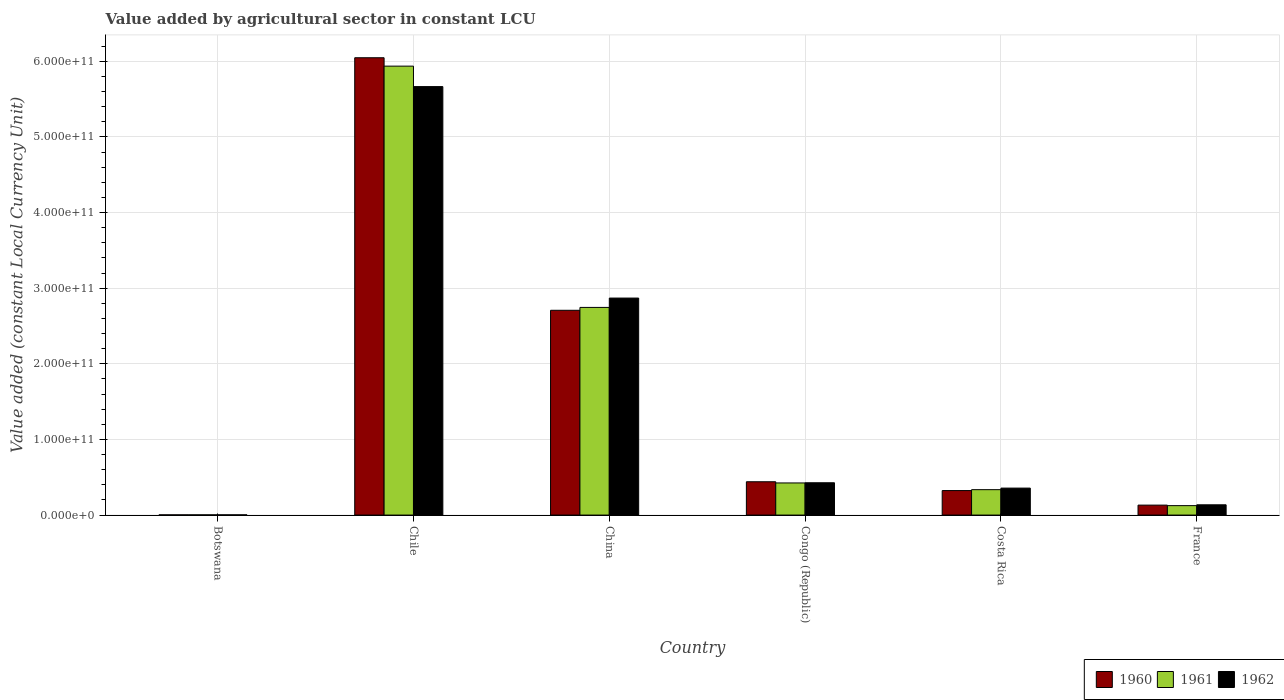How many different coloured bars are there?
Your response must be concise. 3. Are the number of bars per tick equal to the number of legend labels?
Offer a very short reply. Yes. Are the number of bars on each tick of the X-axis equal?
Provide a succinct answer. Yes. How many bars are there on the 4th tick from the left?
Provide a succinct answer. 3. How many bars are there on the 2nd tick from the right?
Ensure brevity in your answer.  3. What is the label of the 5th group of bars from the left?
Your answer should be very brief. Costa Rica. In how many cases, is the number of bars for a given country not equal to the number of legend labels?
Keep it short and to the point. 0. What is the value added by agricultural sector in 1960 in Botswana?
Offer a terse response. 2.79e+08. Across all countries, what is the maximum value added by agricultural sector in 1960?
Ensure brevity in your answer.  6.05e+11. Across all countries, what is the minimum value added by agricultural sector in 1962?
Ensure brevity in your answer.  2.96e+08. In which country was the value added by agricultural sector in 1961 minimum?
Give a very brief answer. Botswana. What is the total value added by agricultural sector in 1962 in the graph?
Offer a very short reply. 9.46e+11. What is the difference between the value added by agricultural sector in 1962 in Chile and that in Congo (Republic)?
Offer a very short reply. 5.24e+11. What is the difference between the value added by agricultural sector in 1962 in Chile and the value added by agricultural sector in 1961 in Congo (Republic)?
Provide a short and direct response. 5.24e+11. What is the average value added by agricultural sector in 1961 per country?
Provide a short and direct response. 1.59e+11. What is the difference between the value added by agricultural sector of/in 1961 and value added by agricultural sector of/in 1962 in China?
Offer a terse response. -1.24e+1. What is the ratio of the value added by agricultural sector in 1962 in China to that in Costa Rica?
Provide a succinct answer. 8.05. What is the difference between the highest and the second highest value added by agricultural sector in 1960?
Keep it short and to the point. -3.34e+11. What is the difference between the highest and the lowest value added by agricultural sector in 1960?
Give a very brief answer. 6.04e+11. In how many countries, is the value added by agricultural sector in 1962 greater than the average value added by agricultural sector in 1962 taken over all countries?
Your answer should be very brief. 2. Is the sum of the value added by agricultural sector in 1960 in Chile and Congo (Republic) greater than the maximum value added by agricultural sector in 1961 across all countries?
Your answer should be very brief. Yes. What does the 3rd bar from the left in Costa Rica represents?
Offer a terse response. 1962. What does the 3rd bar from the right in France represents?
Your answer should be compact. 1960. Are all the bars in the graph horizontal?
Provide a short and direct response. No. How many countries are there in the graph?
Offer a very short reply. 6. What is the difference between two consecutive major ticks on the Y-axis?
Provide a succinct answer. 1.00e+11. Are the values on the major ticks of Y-axis written in scientific E-notation?
Your response must be concise. Yes. Does the graph contain any zero values?
Offer a very short reply. No. Where does the legend appear in the graph?
Make the answer very short. Bottom right. How many legend labels are there?
Your response must be concise. 3. How are the legend labels stacked?
Give a very brief answer. Horizontal. What is the title of the graph?
Your response must be concise. Value added by agricultural sector in constant LCU. Does "1968" appear as one of the legend labels in the graph?
Keep it short and to the point. No. What is the label or title of the X-axis?
Give a very brief answer. Country. What is the label or title of the Y-axis?
Ensure brevity in your answer.  Value added (constant Local Currency Unit). What is the Value added (constant Local Currency Unit) in 1960 in Botswana?
Your answer should be compact. 2.79e+08. What is the Value added (constant Local Currency Unit) of 1961 in Botswana?
Provide a succinct answer. 2.86e+08. What is the Value added (constant Local Currency Unit) of 1962 in Botswana?
Give a very brief answer. 2.96e+08. What is the Value added (constant Local Currency Unit) of 1960 in Chile?
Offer a very short reply. 6.05e+11. What is the Value added (constant Local Currency Unit) in 1961 in Chile?
Your response must be concise. 5.94e+11. What is the Value added (constant Local Currency Unit) in 1962 in Chile?
Your response must be concise. 5.67e+11. What is the Value added (constant Local Currency Unit) of 1960 in China?
Your answer should be compact. 2.71e+11. What is the Value added (constant Local Currency Unit) of 1961 in China?
Offer a very short reply. 2.75e+11. What is the Value added (constant Local Currency Unit) in 1962 in China?
Give a very brief answer. 2.87e+11. What is the Value added (constant Local Currency Unit) in 1960 in Congo (Republic)?
Make the answer very short. 4.41e+1. What is the Value added (constant Local Currency Unit) of 1961 in Congo (Republic)?
Provide a short and direct response. 4.25e+1. What is the Value added (constant Local Currency Unit) in 1962 in Congo (Republic)?
Keep it short and to the point. 4.27e+1. What is the Value added (constant Local Currency Unit) of 1960 in Costa Rica?
Give a very brief answer. 3.24e+1. What is the Value added (constant Local Currency Unit) in 1961 in Costa Rica?
Provide a succinct answer. 3.36e+1. What is the Value added (constant Local Currency Unit) of 1962 in Costa Rica?
Provide a succinct answer. 3.57e+1. What is the Value added (constant Local Currency Unit) of 1960 in France?
Offer a terse response. 1.32e+1. What is the Value added (constant Local Currency Unit) in 1961 in France?
Make the answer very short. 1.25e+1. What is the Value added (constant Local Currency Unit) in 1962 in France?
Your answer should be very brief. 1.36e+1. Across all countries, what is the maximum Value added (constant Local Currency Unit) of 1960?
Give a very brief answer. 6.05e+11. Across all countries, what is the maximum Value added (constant Local Currency Unit) of 1961?
Give a very brief answer. 5.94e+11. Across all countries, what is the maximum Value added (constant Local Currency Unit) of 1962?
Offer a very short reply. 5.67e+11. Across all countries, what is the minimum Value added (constant Local Currency Unit) in 1960?
Keep it short and to the point. 2.79e+08. Across all countries, what is the minimum Value added (constant Local Currency Unit) of 1961?
Your response must be concise. 2.86e+08. Across all countries, what is the minimum Value added (constant Local Currency Unit) of 1962?
Your answer should be very brief. 2.96e+08. What is the total Value added (constant Local Currency Unit) of 1960 in the graph?
Give a very brief answer. 9.65e+11. What is the total Value added (constant Local Currency Unit) in 1961 in the graph?
Ensure brevity in your answer.  9.57e+11. What is the total Value added (constant Local Currency Unit) of 1962 in the graph?
Provide a succinct answer. 9.46e+11. What is the difference between the Value added (constant Local Currency Unit) of 1960 in Botswana and that in Chile?
Your answer should be very brief. -6.04e+11. What is the difference between the Value added (constant Local Currency Unit) of 1961 in Botswana and that in Chile?
Make the answer very short. -5.93e+11. What is the difference between the Value added (constant Local Currency Unit) in 1962 in Botswana and that in Chile?
Give a very brief answer. -5.66e+11. What is the difference between the Value added (constant Local Currency Unit) in 1960 in Botswana and that in China?
Provide a short and direct response. -2.70e+11. What is the difference between the Value added (constant Local Currency Unit) of 1961 in Botswana and that in China?
Your response must be concise. -2.74e+11. What is the difference between the Value added (constant Local Currency Unit) of 1962 in Botswana and that in China?
Provide a short and direct response. -2.87e+11. What is the difference between the Value added (constant Local Currency Unit) of 1960 in Botswana and that in Congo (Republic)?
Offer a terse response. -4.38e+1. What is the difference between the Value added (constant Local Currency Unit) of 1961 in Botswana and that in Congo (Republic)?
Offer a terse response. -4.22e+1. What is the difference between the Value added (constant Local Currency Unit) of 1962 in Botswana and that in Congo (Republic)?
Offer a terse response. -4.24e+1. What is the difference between the Value added (constant Local Currency Unit) of 1960 in Botswana and that in Costa Rica?
Ensure brevity in your answer.  -3.21e+1. What is the difference between the Value added (constant Local Currency Unit) of 1961 in Botswana and that in Costa Rica?
Offer a very short reply. -3.33e+1. What is the difference between the Value added (constant Local Currency Unit) of 1962 in Botswana and that in Costa Rica?
Your response must be concise. -3.54e+1. What is the difference between the Value added (constant Local Currency Unit) in 1960 in Botswana and that in France?
Keep it short and to the point. -1.29e+1. What is the difference between the Value added (constant Local Currency Unit) of 1961 in Botswana and that in France?
Ensure brevity in your answer.  -1.22e+1. What is the difference between the Value added (constant Local Currency Unit) in 1962 in Botswana and that in France?
Your response must be concise. -1.33e+1. What is the difference between the Value added (constant Local Currency Unit) in 1960 in Chile and that in China?
Give a very brief answer. 3.34e+11. What is the difference between the Value added (constant Local Currency Unit) of 1961 in Chile and that in China?
Your answer should be compact. 3.19e+11. What is the difference between the Value added (constant Local Currency Unit) in 1962 in Chile and that in China?
Provide a succinct answer. 2.80e+11. What is the difference between the Value added (constant Local Currency Unit) of 1960 in Chile and that in Congo (Republic)?
Offer a very short reply. 5.61e+11. What is the difference between the Value added (constant Local Currency Unit) in 1961 in Chile and that in Congo (Republic)?
Ensure brevity in your answer.  5.51e+11. What is the difference between the Value added (constant Local Currency Unit) of 1962 in Chile and that in Congo (Republic)?
Provide a succinct answer. 5.24e+11. What is the difference between the Value added (constant Local Currency Unit) of 1960 in Chile and that in Costa Rica?
Offer a very short reply. 5.72e+11. What is the difference between the Value added (constant Local Currency Unit) in 1961 in Chile and that in Costa Rica?
Your response must be concise. 5.60e+11. What is the difference between the Value added (constant Local Currency Unit) of 1962 in Chile and that in Costa Rica?
Offer a very short reply. 5.31e+11. What is the difference between the Value added (constant Local Currency Unit) in 1960 in Chile and that in France?
Offer a very short reply. 5.92e+11. What is the difference between the Value added (constant Local Currency Unit) in 1961 in Chile and that in France?
Give a very brief answer. 5.81e+11. What is the difference between the Value added (constant Local Currency Unit) in 1962 in Chile and that in France?
Make the answer very short. 5.53e+11. What is the difference between the Value added (constant Local Currency Unit) of 1960 in China and that in Congo (Republic)?
Your response must be concise. 2.27e+11. What is the difference between the Value added (constant Local Currency Unit) in 1961 in China and that in Congo (Republic)?
Provide a succinct answer. 2.32e+11. What is the difference between the Value added (constant Local Currency Unit) of 1962 in China and that in Congo (Republic)?
Your answer should be very brief. 2.44e+11. What is the difference between the Value added (constant Local Currency Unit) of 1960 in China and that in Costa Rica?
Offer a terse response. 2.38e+11. What is the difference between the Value added (constant Local Currency Unit) of 1961 in China and that in Costa Rica?
Your answer should be very brief. 2.41e+11. What is the difference between the Value added (constant Local Currency Unit) of 1962 in China and that in Costa Rica?
Provide a short and direct response. 2.51e+11. What is the difference between the Value added (constant Local Currency Unit) in 1960 in China and that in France?
Offer a very short reply. 2.58e+11. What is the difference between the Value added (constant Local Currency Unit) in 1961 in China and that in France?
Offer a very short reply. 2.62e+11. What is the difference between the Value added (constant Local Currency Unit) in 1962 in China and that in France?
Your answer should be very brief. 2.73e+11. What is the difference between the Value added (constant Local Currency Unit) of 1960 in Congo (Republic) and that in Costa Rica?
Provide a succinct answer. 1.17e+1. What is the difference between the Value added (constant Local Currency Unit) of 1961 in Congo (Republic) and that in Costa Rica?
Make the answer very short. 8.89e+09. What is the difference between the Value added (constant Local Currency Unit) of 1962 in Congo (Republic) and that in Costa Rica?
Provide a succinct answer. 7.08e+09. What is the difference between the Value added (constant Local Currency Unit) in 1960 in Congo (Republic) and that in France?
Provide a short and direct response. 3.09e+1. What is the difference between the Value added (constant Local Currency Unit) of 1961 in Congo (Republic) and that in France?
Give a very brief answer. 3.00e+1. What is the difference between the Value added (constant Local Currency Unit) of 1962 in Congo (Republic) and that in France?
Offer a terse response. 2.92e+1. What is the difference between the Value added (constant Local Currency Unit) of 1960 in Costa Rica and that in France?
Provide a succinct answer. 1.92e+1. What is the difference between the Value added (constant Local Currency Unit) of 1961 in Costa Rica and that in France?
Keep it short and to the point. 2.11e+1. What is the difference between the Value added (constant Local Currency Unit) of 1962 in Costa Rica and that in France?
Your response must be concise. 2.21e+1. What is the difference between the Value added (constant Local Currency Unit) in 1960 in Botswana and the Value added (constant Local Currency Unit) in 1961 in Chile?
Keep it short and to the point. -5.93e+11. What is the difference between the Value added (constant Local Currency Unit) of 1960 in Botswana and the Value added (constant Local Currency Unit) of 1962 in Chile?
Offer a very short reply. -5.66e+11. What is the difference between the Value added (constant Local Currency Unit) in 1961 in Botswana and the Value added (constant Local Currency Unit) in 1962 in Chile?
Keep it short and to the point. -5.66e+11. What is the difference between the Value added (constant Local Currency Unit) in 1960 in Botswana and the Value added (constant Local Currency Unit) in 1961 in China?
Give a very brief answer. -2.74e+11. What is the difference between the Value added (constant Local Currency Unit) in 1960 in Botswana and the Value added (constant Local Currency Unit) in 1962 in China?
Offer a very short reply. -2.87e+11. What is the difference between the Value added (constant Local Currency Unit) in 1961 in Botswana and the Value added (constant Local Currency Unit) in 1962 in China?
Provide a short and direct response. -2.87e+11. What is the difference between the Value added (constant Local Currency Unit) in 1960 in Botswana and the Value added (constant Local Currency Unit) in 1961 in Congo (Republic)?
Keep it short and to the point. -4.22e+1. What is the difference between the Value added (constant Local Currency Unit) in 1960 in Botswana and the Value added (constant Local Currency Unit) in 1962 in Congo (Republic)?
Give a very brief answer. -4.25e+1. What is the difference between the Value added (constant Local Currency Unit) in 1961 in Botswana and the Value added (constant Local Currency Unit) in 1962 in Congo (Republic)?
Your answer should be compact. -4.25e+1. What is the difference between the Value added (constant Local Currency Unit) in 1960 in Botswana and the Value added (constant Local Currency Unit) in 1961 in Costa Rica?
Make the answer very short. -3.33e+1. What is the difference between the Value added (constant Local Currency Unit) of 1960 in Botswana and the Value added (constant Local Currency Unit) of 1962 in Costa Rica?
Offer a very short reply. -3.54e+1. What is the difference between the Value added (constant Local Currency Unit) in 1961 in Botswana and the Value added (constant Local Currency Unit) in 1962 in Costa Rica?
Offer a terse response. -3.54e+1. What is the difference between the Value added (constant Local Currency Unit) of 1960 in Botswana and the Value added (constant Local Currency Unit) of 1961 in France?
Offer a terse response. -1.22e+1. What is the difference between the Value added (constant Local Currency Unit) of 1960 in Botswana and the Value added (constant Local Currency Unit) of 1962 in France?
Your response must be concise. -1.33e+1. What is the difference between the Value added (constant Local Currency Unit) in 1961 in Botswana and the Value added (constant Local Currency Unit) in 1962 in France?
Your answer should be very brief. -1.33e+1. What is the difference between the Value added (constant Local Currency Unit) in 1960 in Chile and the Value added (constant Local Currency Unit) in 1961 in China?
Provide a succinct answer. 3.30e+11. What is the difference between the Value added (constant Local Currency Unit) of 1960 in Chile and the Value added (constant Local Currency Unit) of 1962 in China?
Your response must be concise. 3.18e+11. What is the difference between the Value added (constant Local Currency Unit) of 1961 in Chile and the Value added (constant Local Currency Unit) of 1962 in China?
Give a very brief answer. 3.07e+11. What is the difference between the Value added (constant Local Currency Unit) of 1960 in Chile and the Value added (constant Local Currency Unit) of 1961 in Congo (Republic)?
Your response must be concise. 5.62e+11. What is the difference between the Value added (constant Local Currency Unit) in 1960 in Chile and the Value added (constant Local Currency Unit) in 1962 in Congo (Republic)?
Make the answer very short. 5.62e+11. What is the difference between the Value added (constant Local Currency Unit) in 1961 in Chile and the Value added (constant Local Currency Unit) in 1962 in Congo (Republic)?
Your response must be concise. 5.51e+11. What is the difference between the Value added (constant Local Currency Unit) of 1960 in Chile and the Value added (constant Local Currency Unit) of 1961 in Costa Rica?
Make the answer very short. 5.71e+11. What is the difference between the Value added (constant Local Currency Unit) in 1960 in Chile and the Value added (constant Local Currency Unit) in 1962 in Costa Rica?
Keep it short and to the point. 5.69e+11. What is the difference between the Value added (constant Local Currency Unit) in 1961 in Chile and the Value added (constant Local Currency Unit) in 1962 in Costa Rica?
Make the answer very short. 5.58e+11. What is the difference between the Value added (constant Local Currency Unit) in 1960 in Chile and the Value added (constant Local Currency Unit) in 1961 in France?
Your response must be concise. 5.92e+11. What is the difference between the Value added (constant Local Currency Unit) in 1960 in Chile and the Value added (constant Local Currency Unit) in 1962 in France?
Provide a short and direct response. 5.91e+11. What is the difference between the Value added (constant Local Currency Unit) of 1961 in Chile and the Value added (constant Local Currency Unit) of 1962 in France?
Your answer should be compact. 5.80e+11. What is the difference between the Value added (constant Local Currency Unit) in 1960 in China and the Value added (constant Local Currency Unit) in 1961 in Congo (Republic)?
Ensure brevity in your answer.  2.28e+11. What is the difference between the Value added (constant Local Currency Unit) of 1960 in China and the Value added (constant Local Currency Unit) of 1962 in Congo (Republic)?
Make the answer very short. 2.28e+11. What is the difference between the Value added (constant Local Currency Unit) in 1961 in China and the Value added (constant Local Currency Unit) in 1962 in Congo (Republic)?
Offer a terse response. 2.32e+11. What is the difference between the Value added (constant Local Currency Unit) in 1960 in China and the Value added (constant Local Currency Unit) in 1961 in Costa Rica?
Your answer should be compact. 2.37e+11. What is the difference between the Value added (constant Local Currency Unit) in 1960 in China and the Value added (constant Local Currency Unit) in 1962 in Costa Rica?
Offer a terse response. 2.35e+11. What is the difference between the Value added (constant Local Currency Unit) of 1961 in China and the Value added (constant Local Currency Unit) of 1962 in Costa Rica?
Provide a succinct answer. 2.39e+11. What is the difference between the Value added (constant Local Currency Unit) of 1960 in China and the Value added (constant Local Currency Unit) of 1961 in France?
Your answer should be very brief. 2.58e+11. What is the difference between the Value added (constant Local Currency Unit) of 1960 in China and the Value added (constant Local Currency Unit) of 1962 in France?
Keep it short and to the point. 2.57e+11. What is the difference between the Value added (constant Local Currency Unit) in 1961 in China and the Value added (constant Local Currency Unit) in 1962 in France?
Provide a short and direct response. 2.61e+11. What is the difference between the Value added (constant Local Currency Unit) of 1960 in Congo (Republic) and the Value added (constant Local Currency Unit) of 1961 in Costa Rica?
Your answer should be compact. 1.05e+1. What is the difference between the Value added (constant Local Currency Unit) in 1960 in Congo (Republic) and the Value added (constant Local Currency Unit) in 1962 in Costa Rica?
Offer a terse response. 8.40e+09. What is the difference between the Value added (constant Local Currency Unit) in 1961 in Congo (Republic) and the Value added (constant Local Currency Unit) in 1962 in Costa Rica?
Keep it short and to the point. 6.83e+09. What is the difference between the Value added (constant Local Currency Unit) of 1960 in Congo (Republic) and the Value added (constant Local Currency Unit) of 1961 in France?
Your answer should be very brief. 3.16e+1. What is the difference between the Value added (constant Local Currency Unit) in 1960 in Congo (Republic) and the Value added (constant Local Currency Unit) in 1962 in France?
Provide a succinct answer. 3.05e+1. What is the difference between the Value added (constant Local Currency Unit) of 1961 in Congo (Republic) and the Value added (constant Local Currency Unit) of 1962 in France?
Offer a terse response. 2.89e+1. What is the difference between the Value added (constant Local Currency Unit) of 1960 in Costa Rica and the Value added (constant Local Currency Unit) of 1961 in France?
Offer a terse response. 1.99e+1. What is the difference between the Value added (constant Local Currency Unit) in 1960 in Costa Rica and the Value added (constant Local Currency Unit) in 1962 in France?
Your answer should be compact. 1.88e+1. What is the difference between the Value added (constant Local Currency Unit) in 1961 in Costa Rica and the Value added (constant Local Currency Unit) in 1962 in France?
Offer a very short reply. 2.00e+1. What is the average Value added (constant Local Currency Unit) in 1960 per country?
Make the answer very short. 1.61e+11. What is the average Value added (constant Local Currency Unit) of 1961 per country?
Provide a succinct answer. 1.59e+11. What is the average Value added (constant Local Currency Unit) of 1962 per country?
Your answer should be very brief. 1.58e+11. What is the difference between the Value added (constant Local Currency Unit) of 1960 and Value added (constant Local Currency Unit) of 1961 in Botswana?
Offer a very short reply. -6.88e+06. What is the difference between the Value added (constant Local Currency Unit) of 1960 and Value added (constant Local Currency Unit) of 1962 in Botswana?
Offer a terse response. -1.72e+07. What is the difference between the Value added (constant Local Currency Unit) in 1961 and Value added (constant Local Currency Unit) in 1962 in Botswana?
Your answer should be very brief. -1.03e+07. What is the difference between the Value added (constant Local Currency Unit) in 1960 and Value added (constant Local Currency Unit) in 1961 in Chile?
Provide a short and direct response. 1.11e+1. What is the difference between the Value added (constant Local Currency Unit) in 1960 and Value added (constant Local Currency Unit) in 1962 in Chile?
Ensure brevity in your answer.  3.82e+1. What is the difference between the Value added (constant Local Currency Unit) in 1961 and Value added (constant Local Currency Unit) in 1962 in Chile?
Your answer should be very brief. 2.70e+1. What is the difference between the Value added (constant Local Currency Unit) in 1960 and Value added (constant Local Currency Unit) in 1961 in China?
Ensure brevity in your answer.  -3.79e+09. What is the difference between the Value added (constant Local Currency Unit) of 1960 and Value added (constant Local Currency Unit) of 1962 in China?
Keep it short and to the point. -1.61e+1. What is the difference between the Value added (constant Local Currency Unit) in 1961 and Value added (constant Local Currency Unit) in 1962 in China?
Your answer should be very brief. -1.24e+1. What is the difference between the Value added (constant Local Currency Unit) of 1960 and Value added (constant Local Currency Unit) of 1961 in Congo (Republic)?
Make the answer very short. 1.57e+09. What is the difference between the Value added (constant Local Currency Unit) in 1960 and Value added (constant Local Currency Unit) in 1962 in Congo (Republic)?
Offer a terse response. 1.32e+09. What is the difference between the Value added (constant Local Currency Unit) of 1961 and Value added (constant Local Currency Unit) of 1962 in Congo (Republic)?
Ensure brevity in your answer.  -2.56e+08. What is the difference between the Value added (constant Local Currency Unit) of 1960 and Value added (constant Local Currency Unit) of 1961 in Costa Rica?
Give a very brief answer. -1.19e+09. What is the difference between the Value added (constant Local Currency Unit) of 1960 and Value added (constant Local Currency Unit) of 1962 in Costa Rica?
Offer a very short reply. -3.25e+09. What is the difference between the Value added (constant Local Currency Unit) of 1961 and Value added (constant Local Currency Unit) of 1962 in Costa Rica?
Offer a terse response. -2.06e+09. What is the difference between the Value added (constant Local Currency Unit) in 1960 and Value added (constant Local Currency Unit) in 1961 in France?
Ensure brevity in your answer.  6.84e+08. What is the difference between the Value added (constant Local Currency Unit) of 1960 and Value added (constant Local Currency Unit) of 1962 in France?
Offer a very short reply. -4.23e+08. What is the difference between the Value added (constant Local Currency Unit) in 1961 and Value added (constant Local Currency Unit) in 1962 in France?
Your answer should be very brief. -1.11e+09. What is the ratio of the Value added (constant Local Currency Unit) of 1960 in Botswana to that in Chile?
Provide a succinct answer. 0. What is the ratio of the Value added (constant Local Currency Unit) in 1962 in Botswana to that in Chile?
Your answer should be very brief. 0. What is the ratio of the Value added (constant Local Currency Unit) of 1960 in Botswana to that in China?
Provide a succinct answer. 0. What is the ratio of the Value added (constant Local Currency Unit) in 1962 in Botswana to that in China?
Your response must be concise. 0. What is the ratio of the Value added (constant Local Currency Unit) in 1960 in Botswana to that in Congo (Republic)?
Give a very brief answer. 0.01. What is the ratio of the Value added (constant Local Currency Unit) in 1961 in Botswana to that in Congo (Republic)?
Provide a succinct answer. 0.01. What is the ratio of the Value added (constant Local Currency Unit) of 1962 in Botswana to that in Congo (Republic)?
Make the answer very short. 0.01. What is the ratio of the Value added (constant Local Currency Unit) in 1960 in Botswana to that in Costa Rica?
Keep it short and to the point. 0.01. What is the ratio of the Value added (constant Local Currency Unit) in 1961 in Botswana to that in Costa Rica?
Make the answer very short. 0.01. What is the ratio of the Value added (constant Local Currency Unit) in 1962 in Botswana to that in Costa Rica?
Give a very brief answer. 0.01. What is the ratio of the Value added (constant Local Currency Unit) of 1960 in Botswana to that in France?
Keep it short and to the point. 0.02. What is the ratio of the Value added (constant Local Currency Unit) of 1961 in Botswana to that in France?
Make the answer very short. 0.02. What is the ratio of the Value added (constant Local Currency Unit) of 1962 in Botswana to that in France?
Provide a succinct answer. 0.02. What is the ratio of the Value added (constant Local Currency Unit) in 1960 in Chile to that in China?
Provide a short and direct response. 2.23. What is the ratio of the Value added (constant Local Currency Unit) of 1961 in Chile to that in China?
Provide a short and direct response. 2.16. What is the ratio of the Value added (constant Local Currency Unit) of 1962 in Chile to that in China?
Your answer should be very brief. 1.97. What is the ratio of the Value added (constant Local Currency Unit) in 1960 in Chile to that in Congo (Republic)?
Give a very brief answer. 13.73. What is the ratio of the Value added (constant Local Currency Unit) of 1961 in Chile to that in Congo (Republic)?
Offer a terse response. 13.97. What is the ratio of the Value added (constant Local Currency Unit) of 1962 in Chile to that in Congo (Republic)?
Provide a succinct answer. 13.26. What is the ratio of the Value added (constant Local Currency Unit) in 1960 in Chile to that in Costa Rica?
Ensure brevity in your answer.  18.66. What is the ratio of the Value added (constant Local Currency Unit) of 1961 in Chile to that in Costa Rica?
Your response must be concise. 17.67. What is the ratio of the Value added (constant Local Currency Unit) in 1962 in Chile to that in Costa Rica?
Ensure brevity in your answer.  15.89. What is the ratio of the Value added (constant Local Currency Unit) in 1960 in Chile to that in France?
Offer a terse response. 45.96. What is the ratio of the Value added (constant Local Currency Unit) in 1961 in Chile to that in France?
Your response must be concise. 47.59. What is the ratio of the Value added (constant Local Currency Unit) in 1962 in Chile to that in France?
Your response must be concise. 41.72. What is the ratio of the Value added (constant Local Currency Unit) of 1960 in China to that in Congo (Republic)?
Make the answer very short. 6.15. What is the ratio of the Value added (constant Local Currency Unit) in 1961 in China to that in Congo (Republic)?
Offer a very short reply. 6.46. What is the ratio of the Value added (constant Local Currency Unit) in 1962 in China to that in Congo (Republic)?
Provide a short and direct response. 6.71. What is the ratio of the Value added (constant Local Currency Unit) in 1960 in China to that in Costa Rica?
Ensure brevity in your answer.  8.36. What is the ratio of the Value added (constant Local Currency Unit) in 1961 in China to that in Costa Rica?
Offer a terse response. 8.17. What is the ratio of the Value added (constant Local Currency Unit) of 1962 in China to that in Costa Rica?
Provide a short and direct response. 8.05. What is the ratio of the Value added (constant Local Currency Unit) in 1960 in China to that in France?
Ensure brevity in your answer.  20.58. What is the ratio of the Value added (constant Local Currency Unit) of 1961 in China to that in France?
Offer a very short reply. 22.01. What is the ratio of the Value added (constant Local Currency Unit) of 1962 in China to that in France?
Make the answer very short. 21.13. What is the ratio of the Value added (constant Local Currency Unit) of 1960 in Congo (Republic) to that in Costa Rica?
Offer a very short reply. 1.36. What is the ratio of the Value added (constant Local Currency Unit) of 1961 in Congo (Republic) to that in Costa Rica?
Provide a short and direct response. 1.26. What is the ratio of the Value added (constant Local Currency Unit) in 1962 in Congo (Republic) to that in Costa Rica?
Your answer should be very brief. 1.2. What is the ratio of the Value added (constant Local Currency Unit) of 1960 in Congo (Republic) to that in France?
Offer a terse response. 3.35. What is the ratio of the Value added (constant Local Currency Unit) of 1961 in Congo (Republic) to that in France?
Your response must be concise. 3.41. What is the ratio of the Value added (constant Local Currency Unit) in 1962 in Congo (Republic) to that in France?
Your response must be concise. 3.15. What is the ratio of the Value added (constant Local Currency Unit) in 1960 in Costa Rica to that in France?
Provide a succinct answer. 2.46. What is the ratio of the Value added (constant Local Currency Unit) of 1961 in Costa Rica to that in France?
Ensure brevity in your answer.  2.69. What is the ratio of the Value added (constant Local Currency Unit) in 1962 in Costa Rica to that in France?
Offer a terse response. 2.63. What is the difference between the highest and the second highest Value added (constant Local Currency Unit) of 1960?
Ensure brevity in your answer.  3.34e+11. What is the difference between the highest and the second highest Value added (constant Local Currency Unit) of 1961?
Keep it short and to the point. 3.19e+11. What is the difference between the highest and the second highest Value added (constant Local Currency Unit) of 1962?
Offer a terse response. 2.80e+11. What is the difference between the highest and the lowest Value added (constant Local Currency Unit) in 1960?
Make the answer very short. 6.04e+11. What is the difference between the highest and the lowest Value added (constant Local Currency Unit) in 1961?
Your answer should be compact. 5.93e+11. What is the difference between the highest and the lowest Value added (constant Local Currency Unit) in 1962?
Offer a terse response. 5.66e+11. 